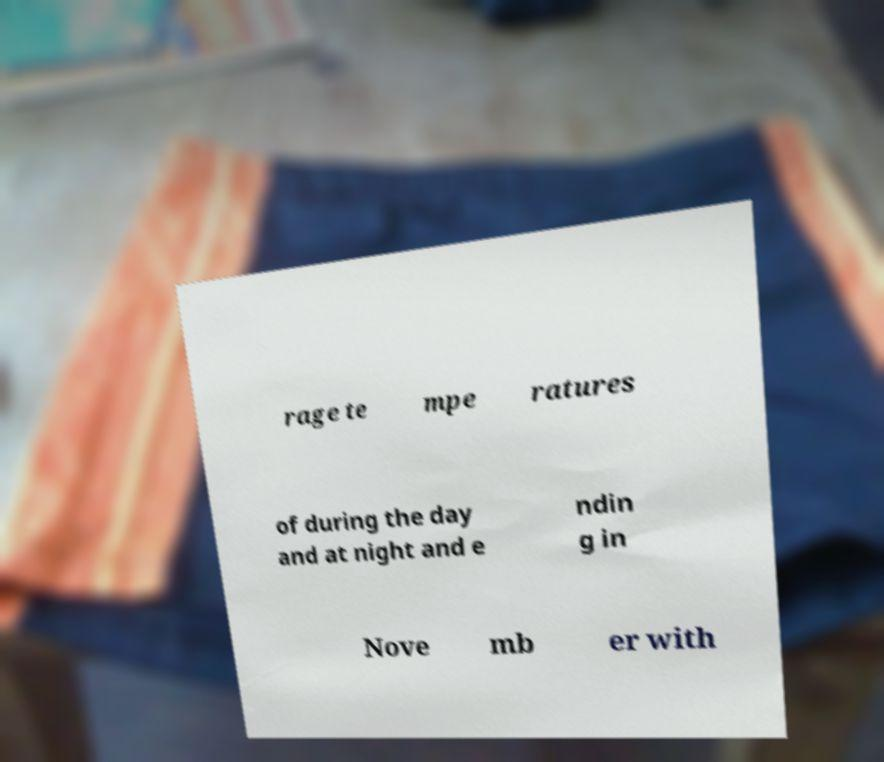Please read and relay the text visible in this image. What does it say? rage te mpe ratures of during the day and at night and e ndin g in Nove mb er with 